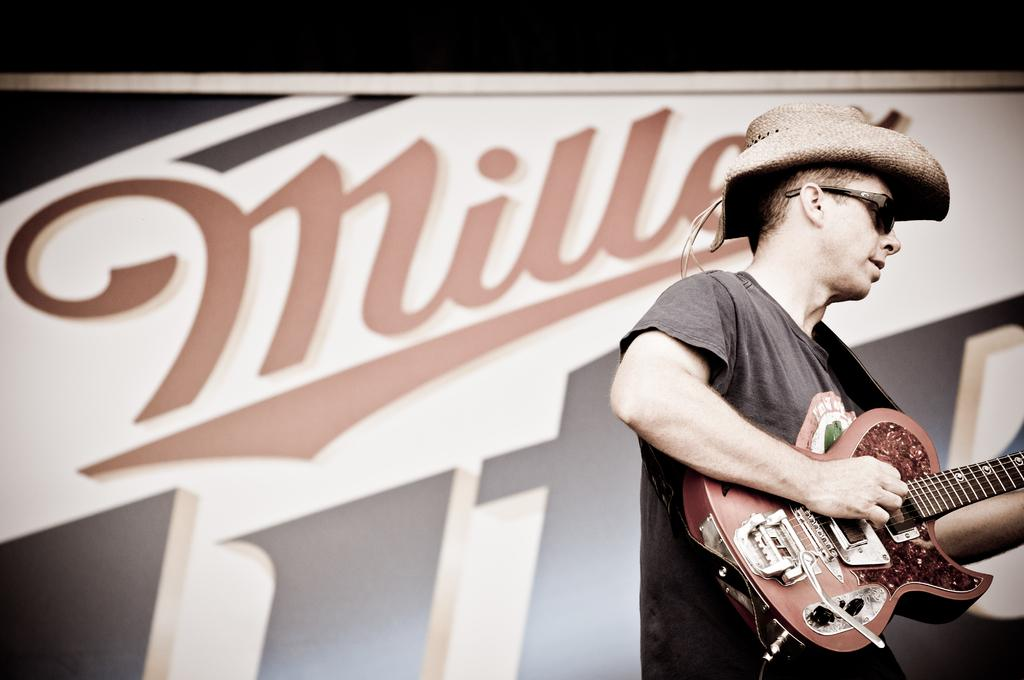What is the man in the image doing? The man is playing a guitar. What accessories is the man wearing in the image? The man is wearing goggles and a cap. What can be seen in the background of the image? There is a banner in the background of the image. What type of doll is sitting on the sidewalk in the image? There is no doll or sidewalk present in the image; it features a man playing a guitar. Can you hear the sound of thunder in the image? There is no sound or indication of thunder in the image. 